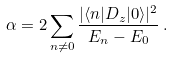<formula> <loc_0><loc_0><loc_500><loc_500>\alpha = 2 \sum _ { n \neq 0 } \frac { | \langle n | D _ { z } | 0 \rangle | ^ { 2 } } { E _ { n } - E _ { 0 } } \, .</formula> 